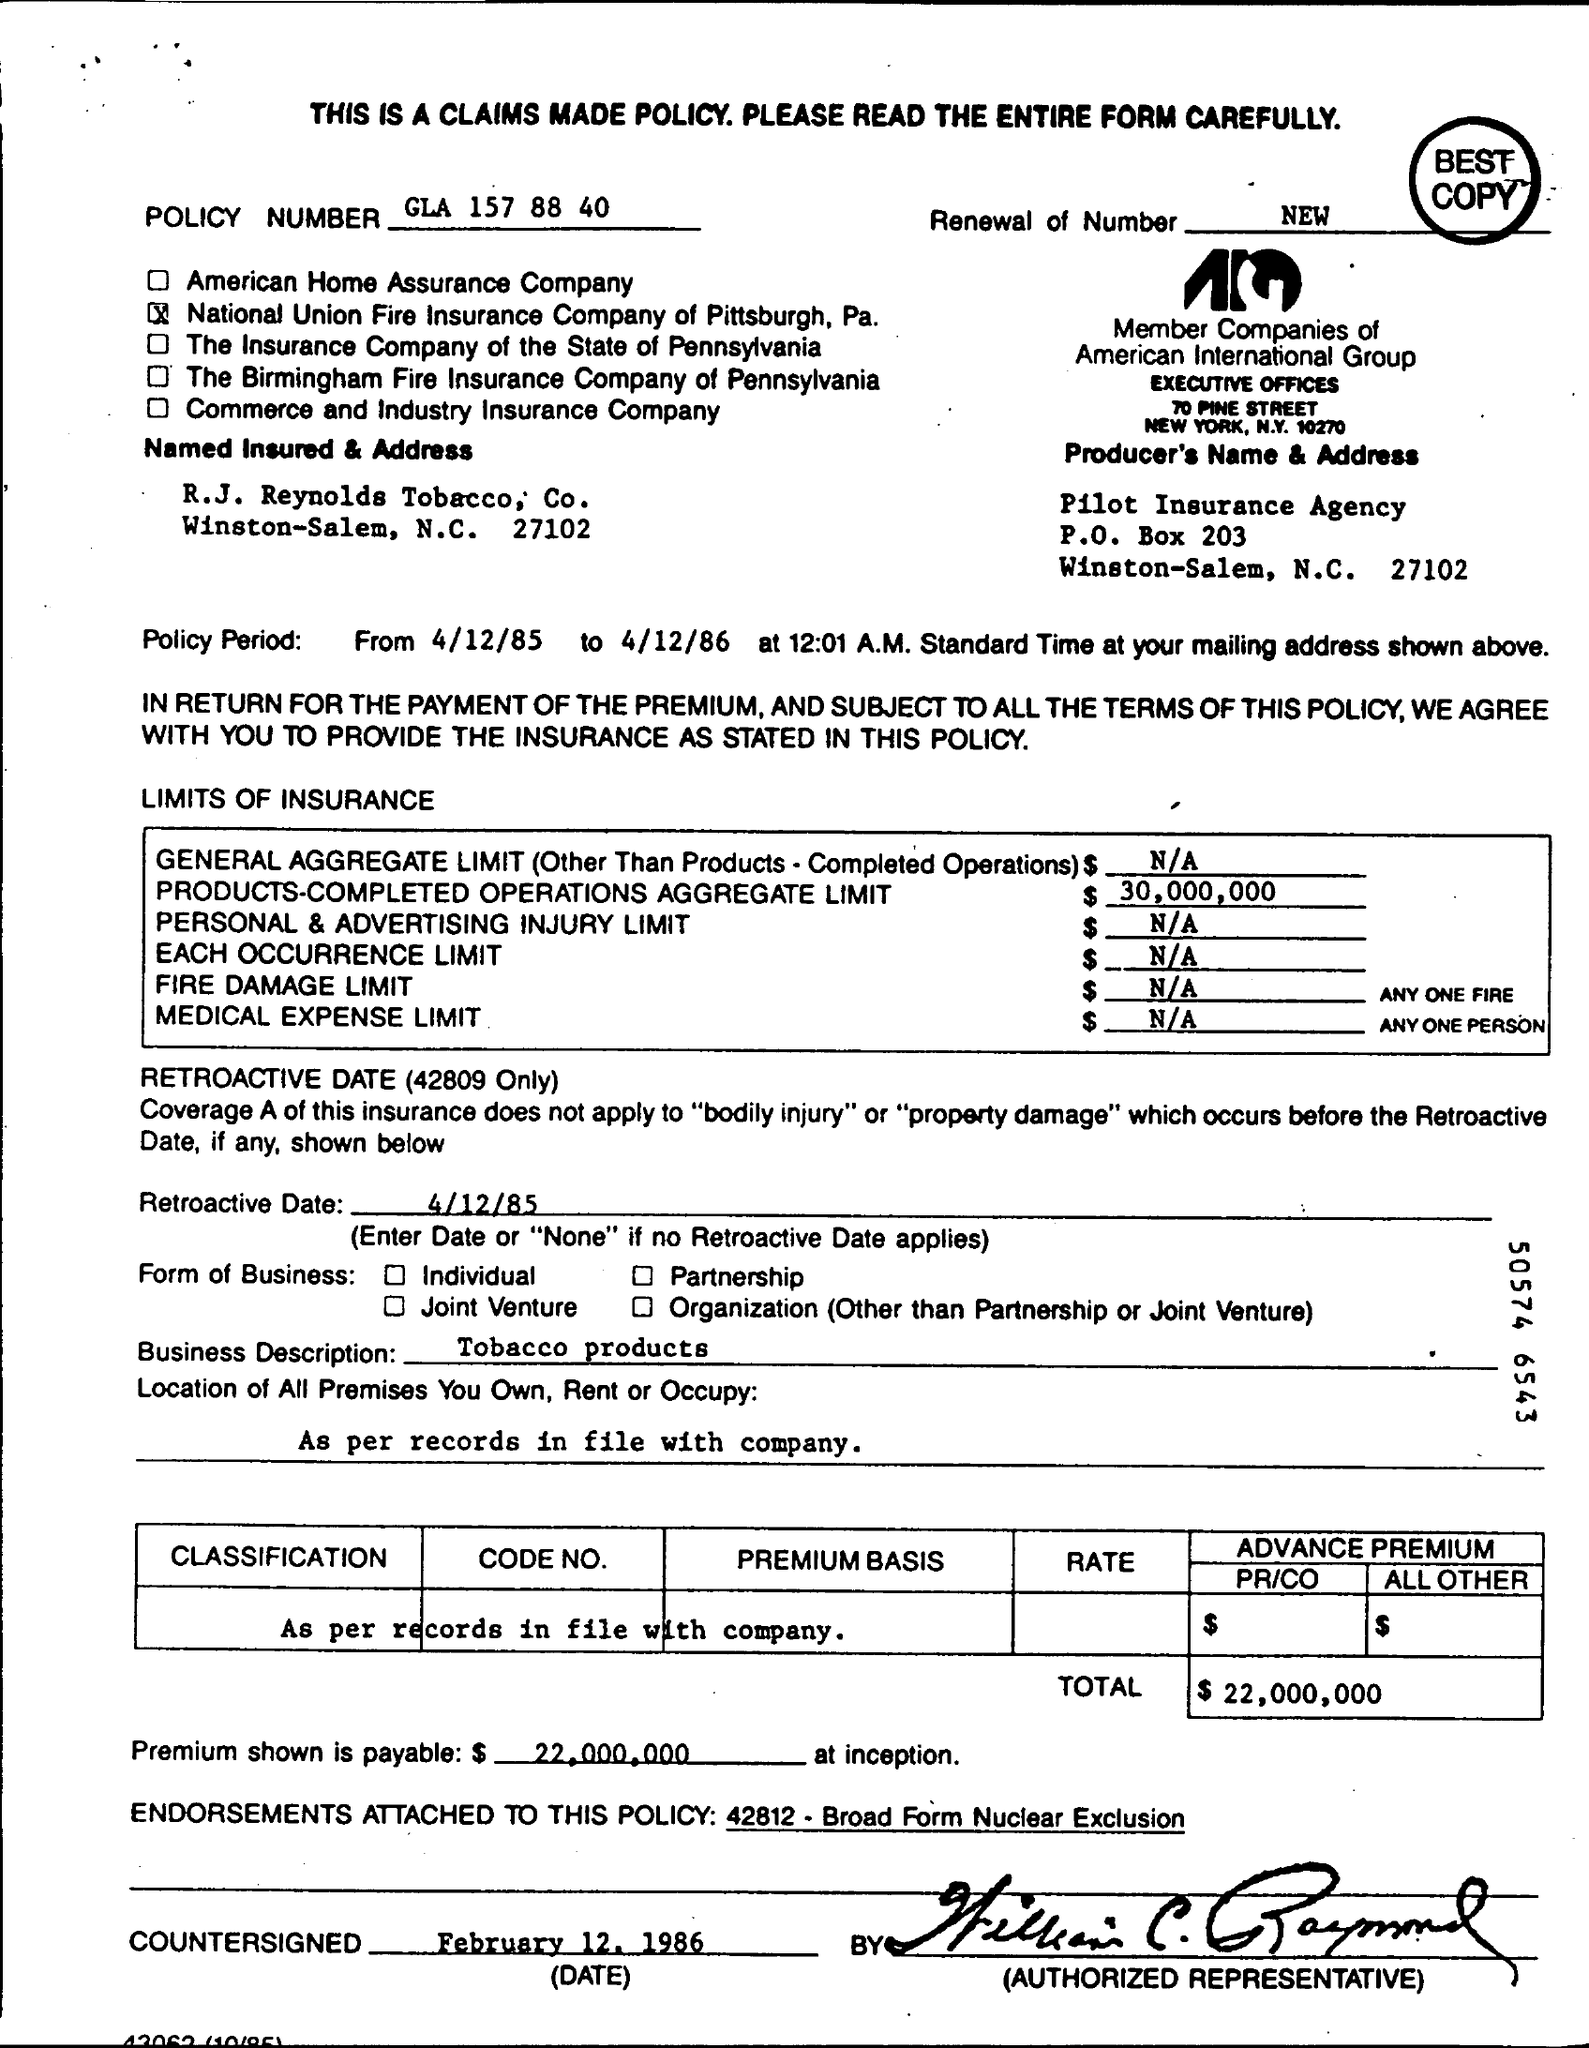What is the policy number?
Your response must be concise. GLA 157 88 40. Which company is insured  this form
Offer a terse response. R.J. Reynolds Tobacco, Co. Which company has produced this policy?
Provide a succinct answer. Pilot Insurance Agency. What is the total cost of this bill?
Your answer should be very brief. $  22,000,000. What's the countersigned  date written on the policy?
Your response must be concise. February 12, 1986. 